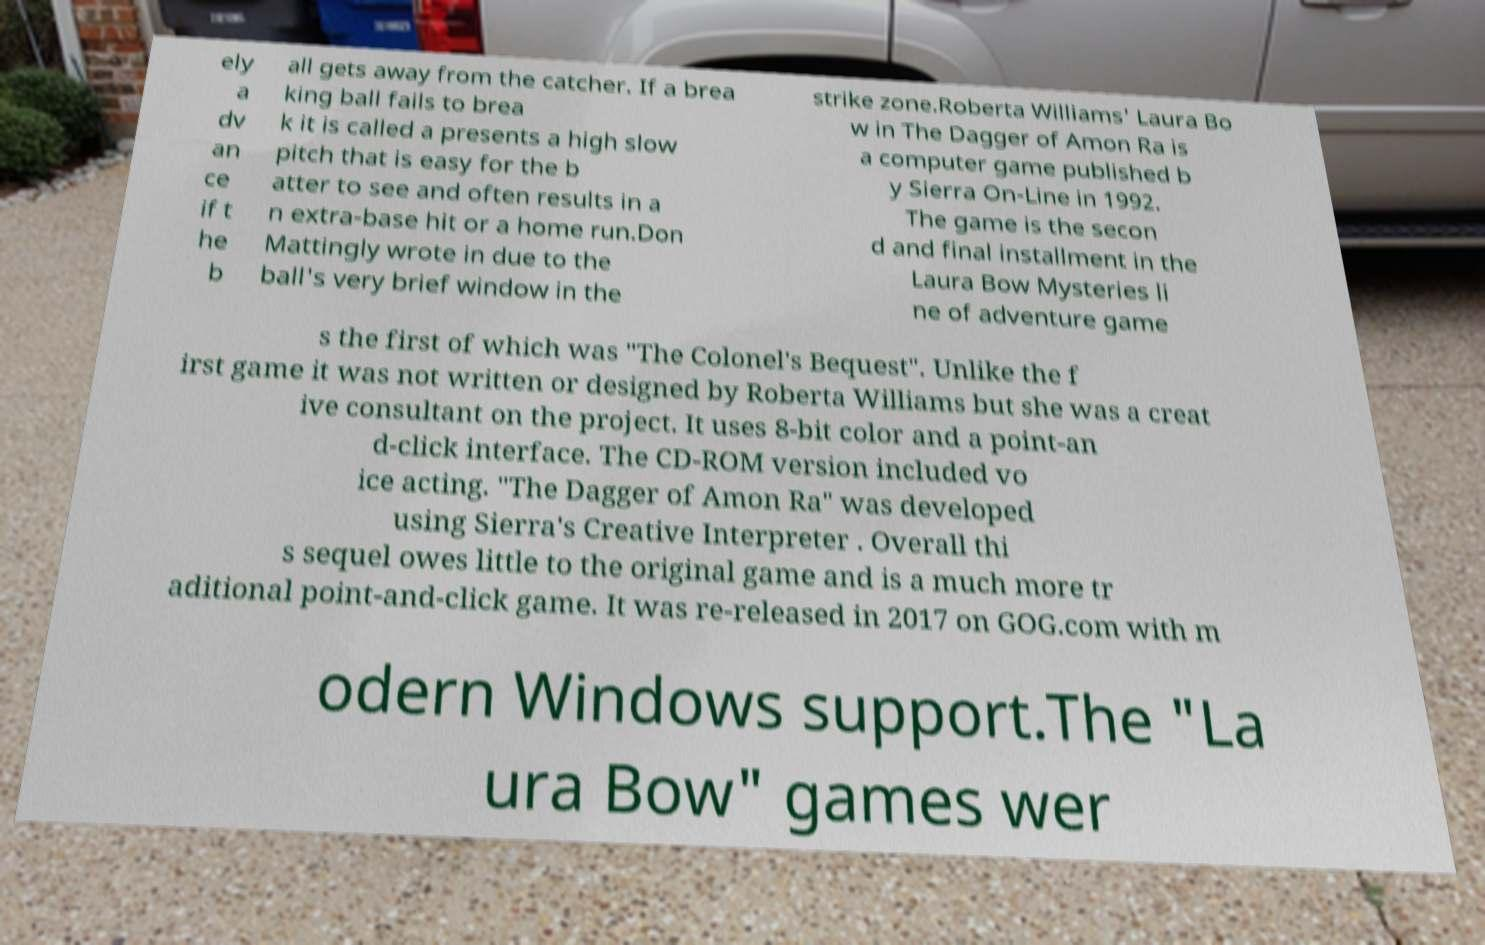For documentation purposes, I need the text within this image transcribed. Could you provide that? ely a dv an ce if t he b all gets away from the catcher. If a brea king ball fails to brea k it is called a presents a high slow pitch that is easy for the b atter to see and often results in a n extra-base hit or a home run.Don Mattingly wrote in due to the ball's very brief window in the strike zone.Roberta Williams' Laura Bo w in The Dagger of Amon Ra is a computer game published b y Sierra On-Line in 1992. The game is the secon d and final installment in the Laura Bow Mysteries li ne of adventure game s the first of which was "The Colonel's Bequest". Unlike the f irst game it was not written or designed by Roberta Williams but she was a creat ive consultant on the project. It uses 8-bit color and a point-an d-click interface. The CD-ROM version included vo ice acting. "The Dagger of Amon Ra" was developed using Sierra's Creative Interpreter . Overall thi s sequel owes little to the original game and is a much more tr aditional point-and-click game. It was re-released in 2017 on GOG.com with m odern Windows support.The "La ura Bow" games wer 